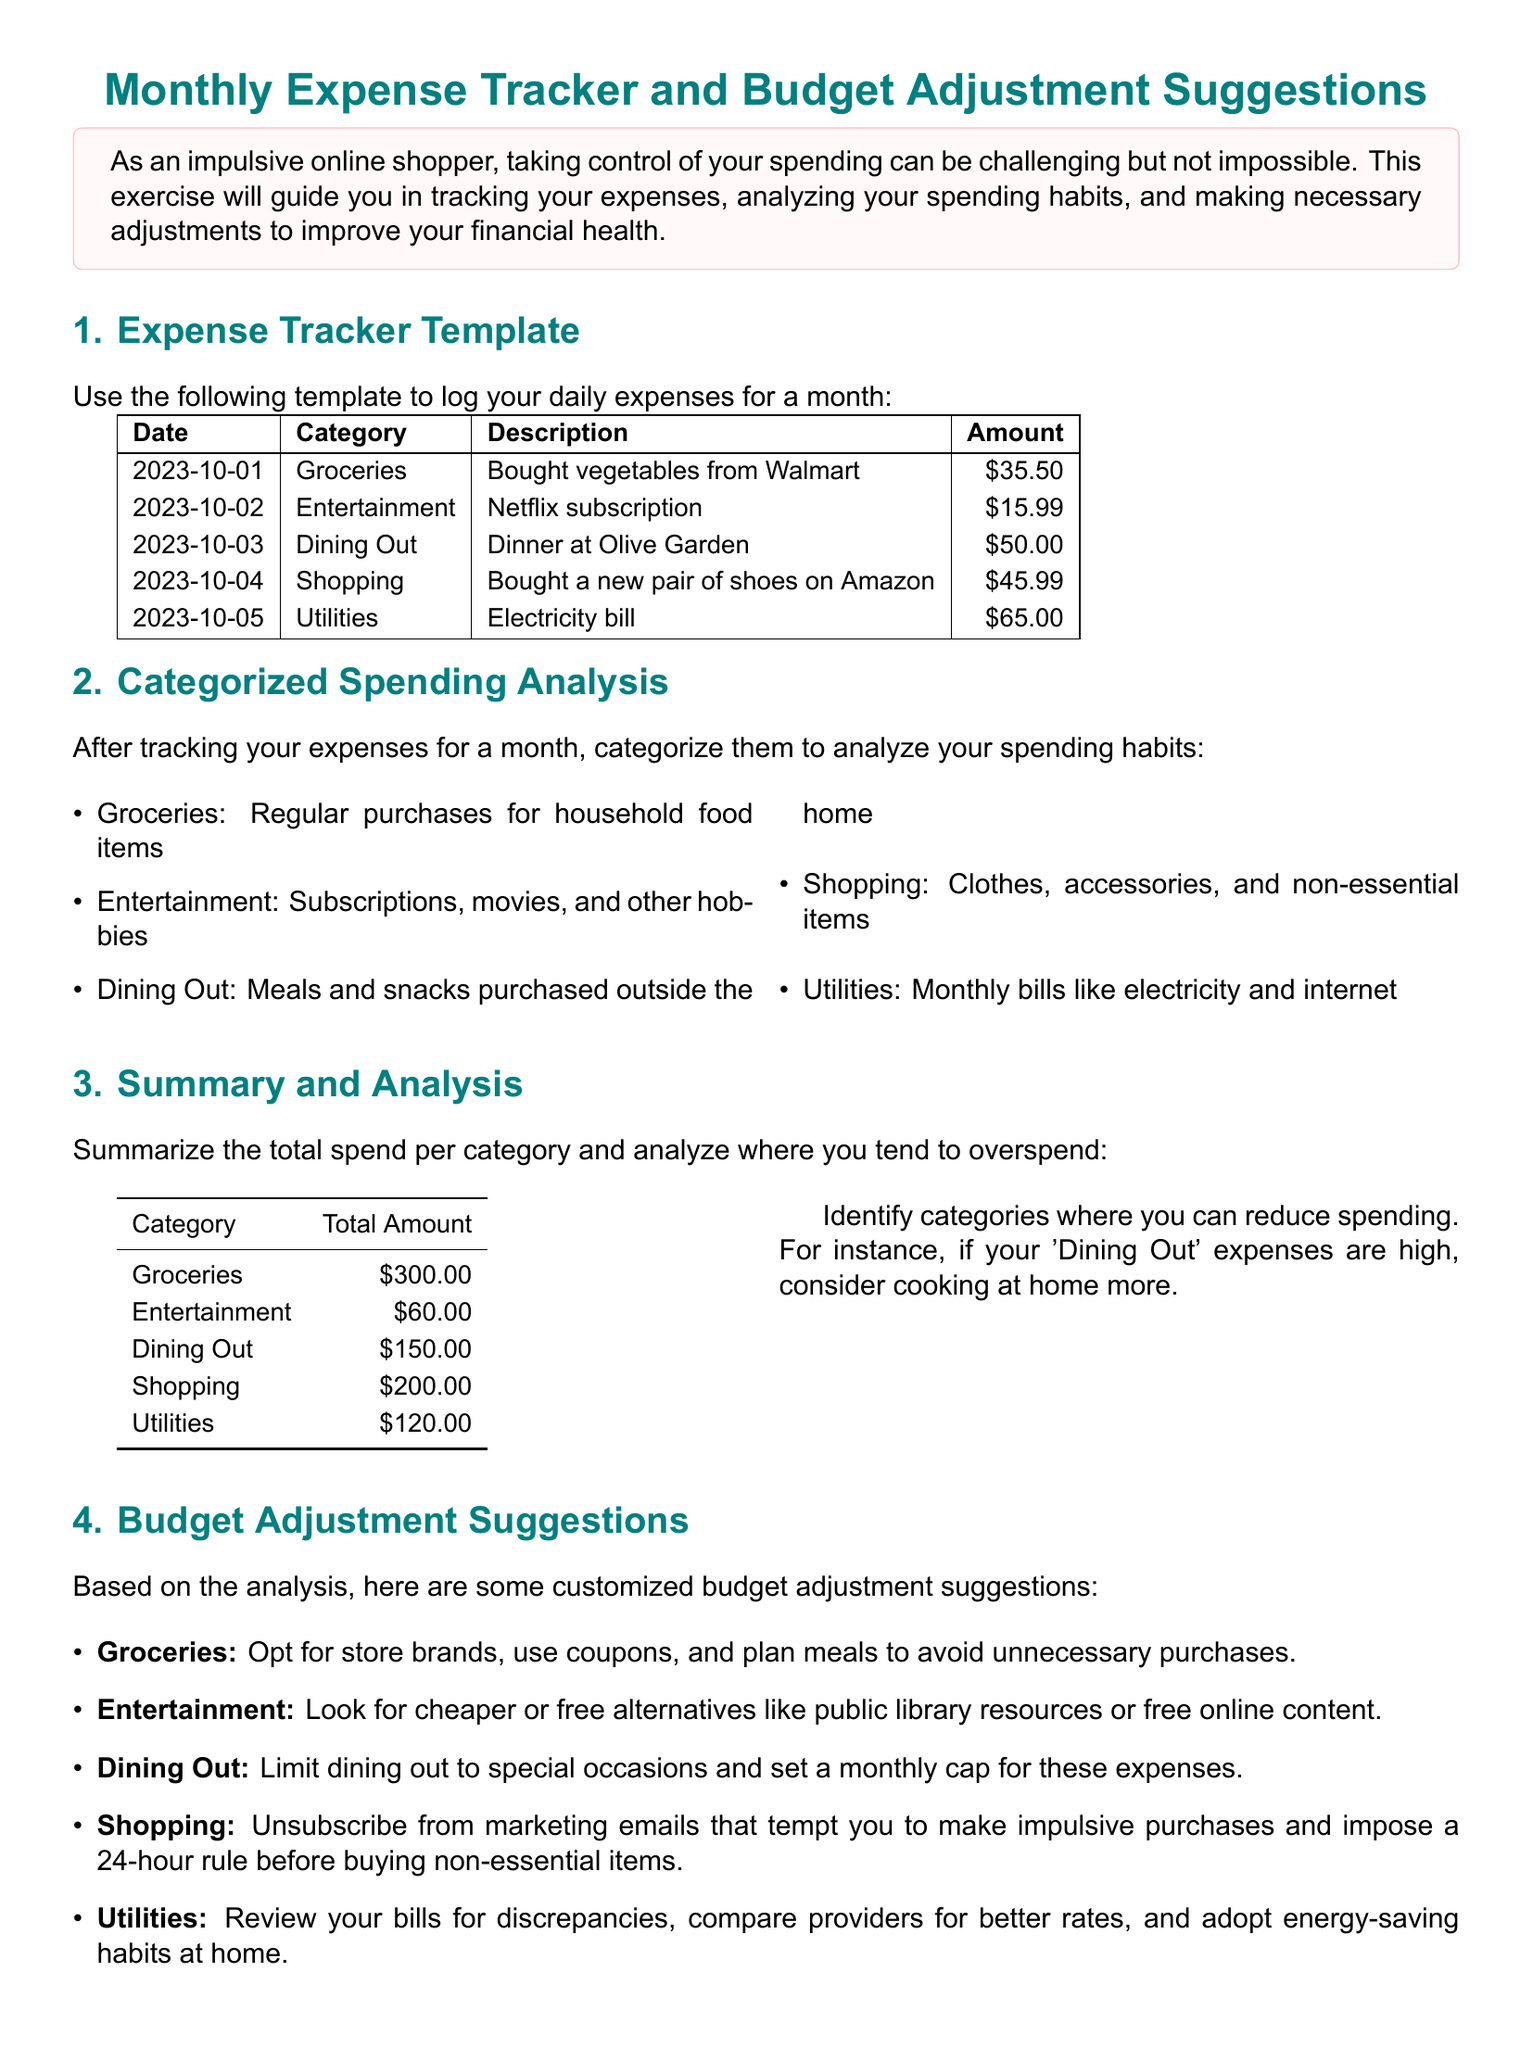what is the total amount spent on Groceries? The total amount spent on Groceries is listed in the summary table under the Groceries category.
Answer: $300.00 what type of expenses are included in the 'Entertainment' category? The document describes what qualifies as Entertainment expenses, which include subscriptions and hobbies.
Answer: Subscriptions, movies, and other hobbies how much was spent on Dining Out? The Dining Out total amount is provided in the summary table under the Dining Out category.
Answer: $150.00 what is one suggestion for reducing Grocery expenses? Suggestions are provided for each category, including Grocery expenses, and they specify methods to save.
Answer: Opt for store brands which category had the highest spending? The summary table provides the total amount for each category, allowing identification of the highest.
Answer: Shopping what is the monthly cap suggestion for Dining Out? The document recommends a specific spending limit for Dining Out to help manage finances.
Answer: A monthly cap identify one way to reduce Utility expenses. Suggestions to reduce Utility expenses are listed, and one of them involves reviewing bills.
Answer: Review your bills what is the reflection focus for future planning? The section on Reflection and Future Planning encourages setting specific goals based on previous spending.
Answer: Set realistic financial goals how should you track expenses according to the document? The exercise emphasizes tracking expenses monthly for better financial management.
Answer: Monthly tracking 